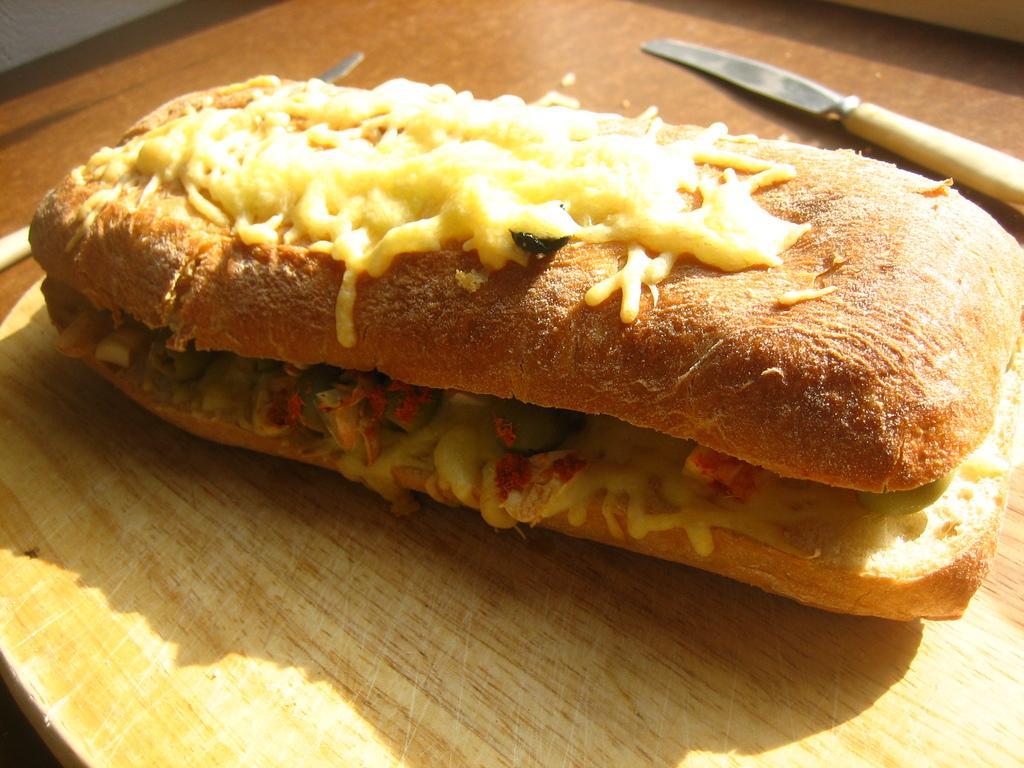Describe this image in one or two sentences. In the picture I can see the burger and two knives on the wooden table. 